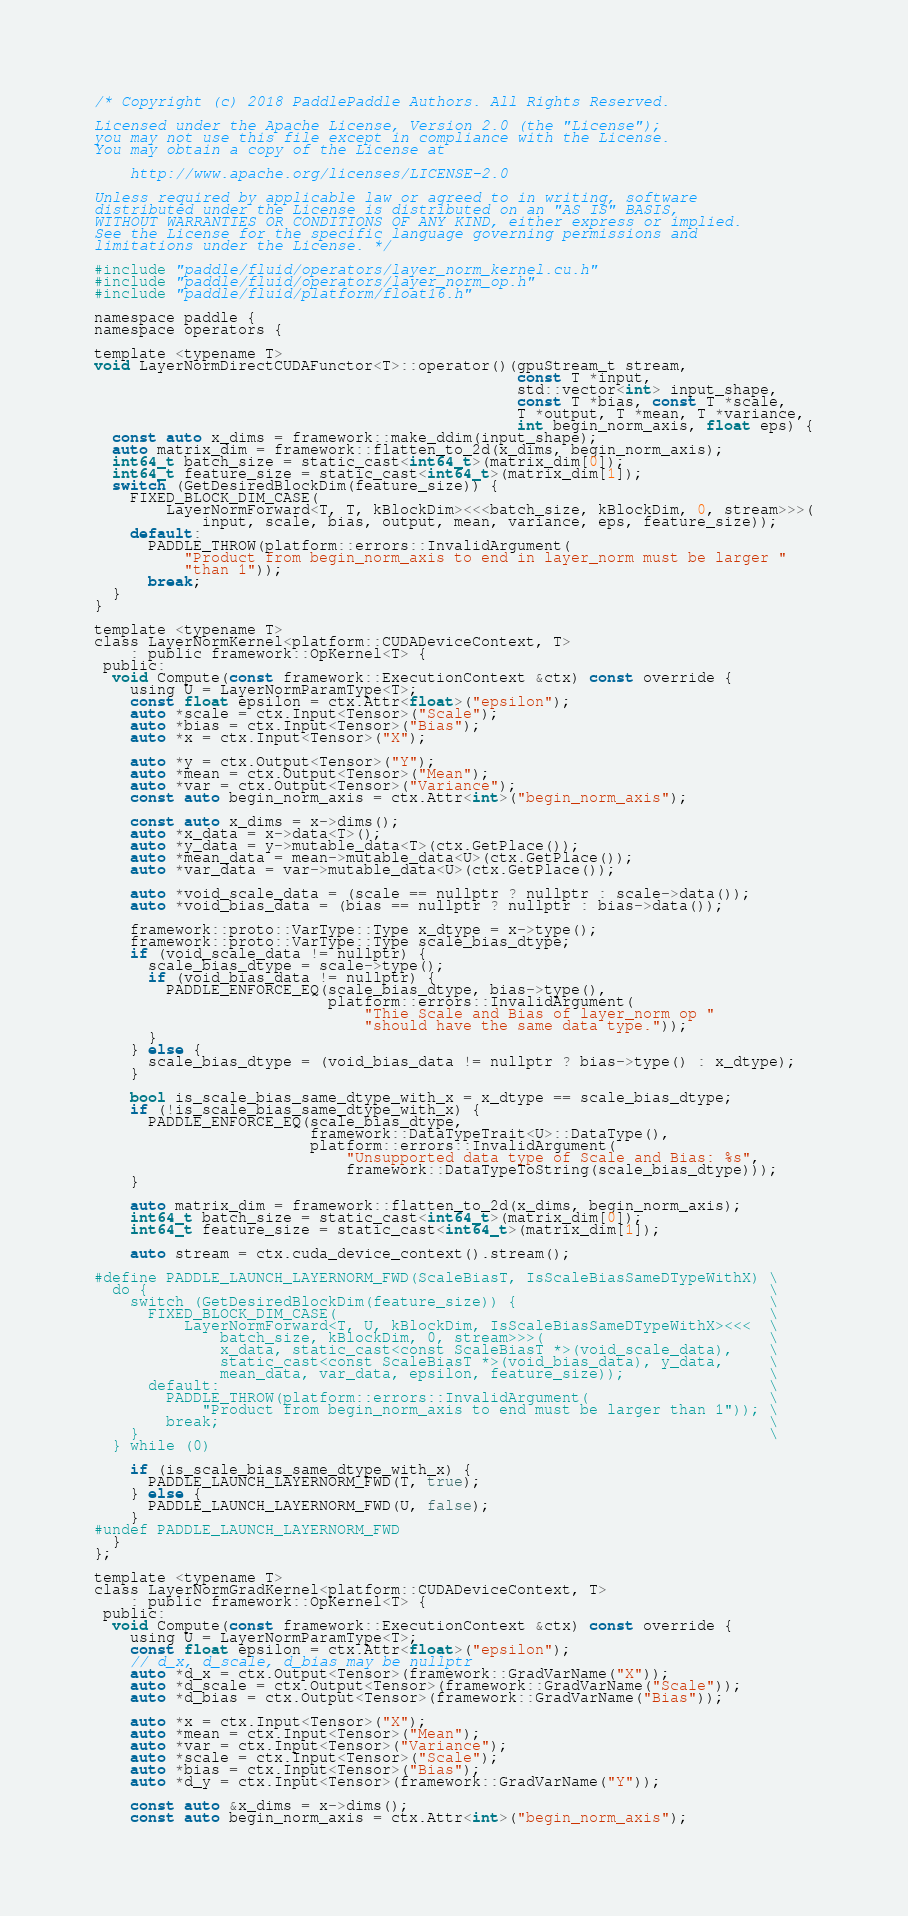<code> <loc_0><loc_0><loc_500><loc_500><_Cuda_>/* Copyright (c) 2018 PaddlePaddle Authors. All Rights Reserved.

Licensed under the Apache License, Version 2.0 (the "License");
you may not use this file except in compliance with the License.
You may obtain a copy of the License at

    http://www.apache.org/licenses/LICENSE-2.0

Unless required by applicable law or agreed to in writing, software
distributed under the License is distributed on an "AS IS" BASIS,
WITHOUT WARRANTIES OR CONDITIONS OF ANY KIND, either express or implied.
See the License for the specific language governing permissions and
limitations under the License. */

#include "paddle/fluid/operators/layer_norm_kernel.cu.h"
#include "paddle/fluid/operators/layer_norm_op.h"
#include "paddle/fluid/platform/float16.h"

namespace paddle {
namespace operators {

template <typename T>
void LayerNormDirectCUDAFunctor<T>::operator()(gpuStream_t stream,
                                               const T *input,
                                               std::vector<int> input_shape,
                                               const T *bias, const T *scale,
                                               T *output, T *mean, T *variance,
                                               int begin_norm_axis, float eps) {
  const auto x_dims = framework::make_ddim(input_shape);
  auto matrix_dim = framework::flatten_to_2d(x_dims, begin_norm_axis);
  int64_t batch_size = static_cast<int64_t>(matrix_dim[0]);
  int64_t feature_size = static_cast<int64_t>(matrix_dim[1]);
  switch (GetDesiredBlockDim(feature_size)) {
    FIXED_BLOCK_DIM_CASE(
        LayerNormForward<T, T, kBlockDim><<<batch_size, kBlockDim, 0, stream>>>(
            input, scale, bias, output, mean, variance, eps, feature_size));
    default:
      PADDLE_THROW(platform::errors::InvalidArgument(
          "Product from begin_norm_axis to end in layer_norm must be larger "
          "than 1"));
      break;
  }
}

template <typename T>
class LayerNormKernel<platform::CUDADeviceContext, T>
    : public framework::OpKernel<T> {
 public:
  void Compute(const framework::ExecutionContext &ctx) const override {
    using U = LayerNormParamType<T>;
    const float epsilon = ctx.Attr<float>("epsilon");
    auto *scale = ctx.Input<Tensor>("Scale");
    auto *bias = ctx.Input<Tensor>("Bias");
    auto *x = ctx.Input<Tensor>("X");

    auto *y = ctx.Output<Tensor>("Y");
    auto *mean = ctx.Output<Tensor>("Mean");
    auto *var = ctx.Output<Tensor>("Variance");
    const auto begin_norm_axis = ctx.Attr<int>("begin_norm_axis");

    const auto x_dims = x->dims();
    auto *x_data = x->data<T>();
    auto *y_data = y->mutable_data<T>(ctx.GetPlace());
    auto *mean_data = mean->mutable_data<U>(ctx.GetPlace());
    auto *var_data = var->mutable_data<U>(ctx.GetPlace());

    auto *void_scale_data = (scale == nullptr ? nullptr : scale->data());
    auto *void_bias_data = (bias == nullptr ? nullptr : bias->data());

    framework::proto::VarType::Type x_dtype = x->type();
    framework::proto::VarType::Type scale_bias_dtype;
    if (void_scale_data != nullptr) {
      scale_bias_dtype = scale->type();
      if (void_bias_data != nullptr) {
        PADDLE_ENFORCE_EQ(scale_bias_dtype, bias->type(),
                          platform::errors::InvalidArgument(
                              "Thie Scale and Bias of layer_norm op "
                              "should have the same data type."));
      }
    } else {
      scale_bias_dtype = (void_bias_data != nullptr ? bias->type() : x_dtype);
    }

    bool is_scale_bias_same_dtype_with_x = x_dtype == scale_bias_dtype;
    if (!is_scale_bias_same_dtype_with_x) {
      PADDLE_ENFORCE_EQ(scale_bias_dtype,
                        framework::DataTypeTrait<U>::DataType(),
                        platform::errors::InvalidArgument(
                            "Unsupported data type of Scale and Bias: %s",
                            framework::DataTypeToString(scale_bias_dtype)));
    }

    auto matrix_dim = framework::flatten_to_2d(x_dims, begin_norm_axis);
    int64_t batch_size = static_cast<int64_t>(matrix_dim[0]);
    int64_t feature_size = static_cast<int64_t>(matrix_dim[1]);

    auto stream = ctx.cuda_device_context().stream();

#define PADDLE_LAUNCH_LAYERNORM_FWD(ScaleBiasT, IsScaleBiasSameDTypeWithX) \
  do {                                                                     \
    switch (GetDesiredBlockDim(feature_size)) {                            \
      FIXED_BLOCK_DIM_CASE(                                                \
          LayerNormForward<T, U, kBlockDim, IsScaleBiasSameDTypeWithX><<<  \
              batch_size, kBlockDim, 0, stream>>>(                         \
              x_data, static_cast<const ScaleBiasT *>(void_scale_data),    \
              static_cast<const ScaleBiasT *>(void_bias_data), y_data,     \
              mean_data, var_data, epsilon, feature_size));                \
      default:                                                             \
        PADDLE_THROW(platform::errors::InvalidArgument(                    \
            "Product from begin_norm_axis to end must be larger than 1")); \
        break;                                                             \
    }                                                                      \
  } while (0)

    if (is_scale_bias_same_dtype_with_x) {
      PADDLE_LAUNCH_LAYERNORM_FWD(T, true);
    } else {
      PADDLE_LAUNCH_LAYERNORM_FWD(U, false);
    }
#undef PADDLE_LAUNCH_LAYERNORM_FWD
  }
};

template <typename T>
class LayerNormGradKernel<platform::CUDADeviceContext, T>
    : public framework::OpKernel<T> {
 public:
  void Compute(const framework::ExecutionContext &ctx) const override {
    using U = LayerNormParamType<T>;
    const float epsilon = ctx.Attr<float>("epsilon");
    // d_x, d_scale, d_bias may be nullptr
    auto *d_x = ctx.Output<Tensor>(framework::GradVarName("X"));
    auto *d_scale = ctx.Output<Tensor>(framework::GradVarName("Scale"));
    auto *d_bias = ctx.Output<Tensor>(framework::GradVarName("Bias"));

    auto *x = ctx.Input<Tensor>("X");
    auto *mean = ctx.Input<Tensor>("Mean");
    auto *var = ctx.Input<Tensor>("Variance");
    auto *scale = ctx.Input<Tensor>("Scale");
    auto *bias = ctx.Input<Tensor>("Bias");
    auto *d_y = ctx.Input<Tensor>(framework::GradVarName("Y"));

    const auto &x_dims = x->dims();
    const auto begin_norm_axis = ctx.Attr<int>("begin_norm_axis");</code> 